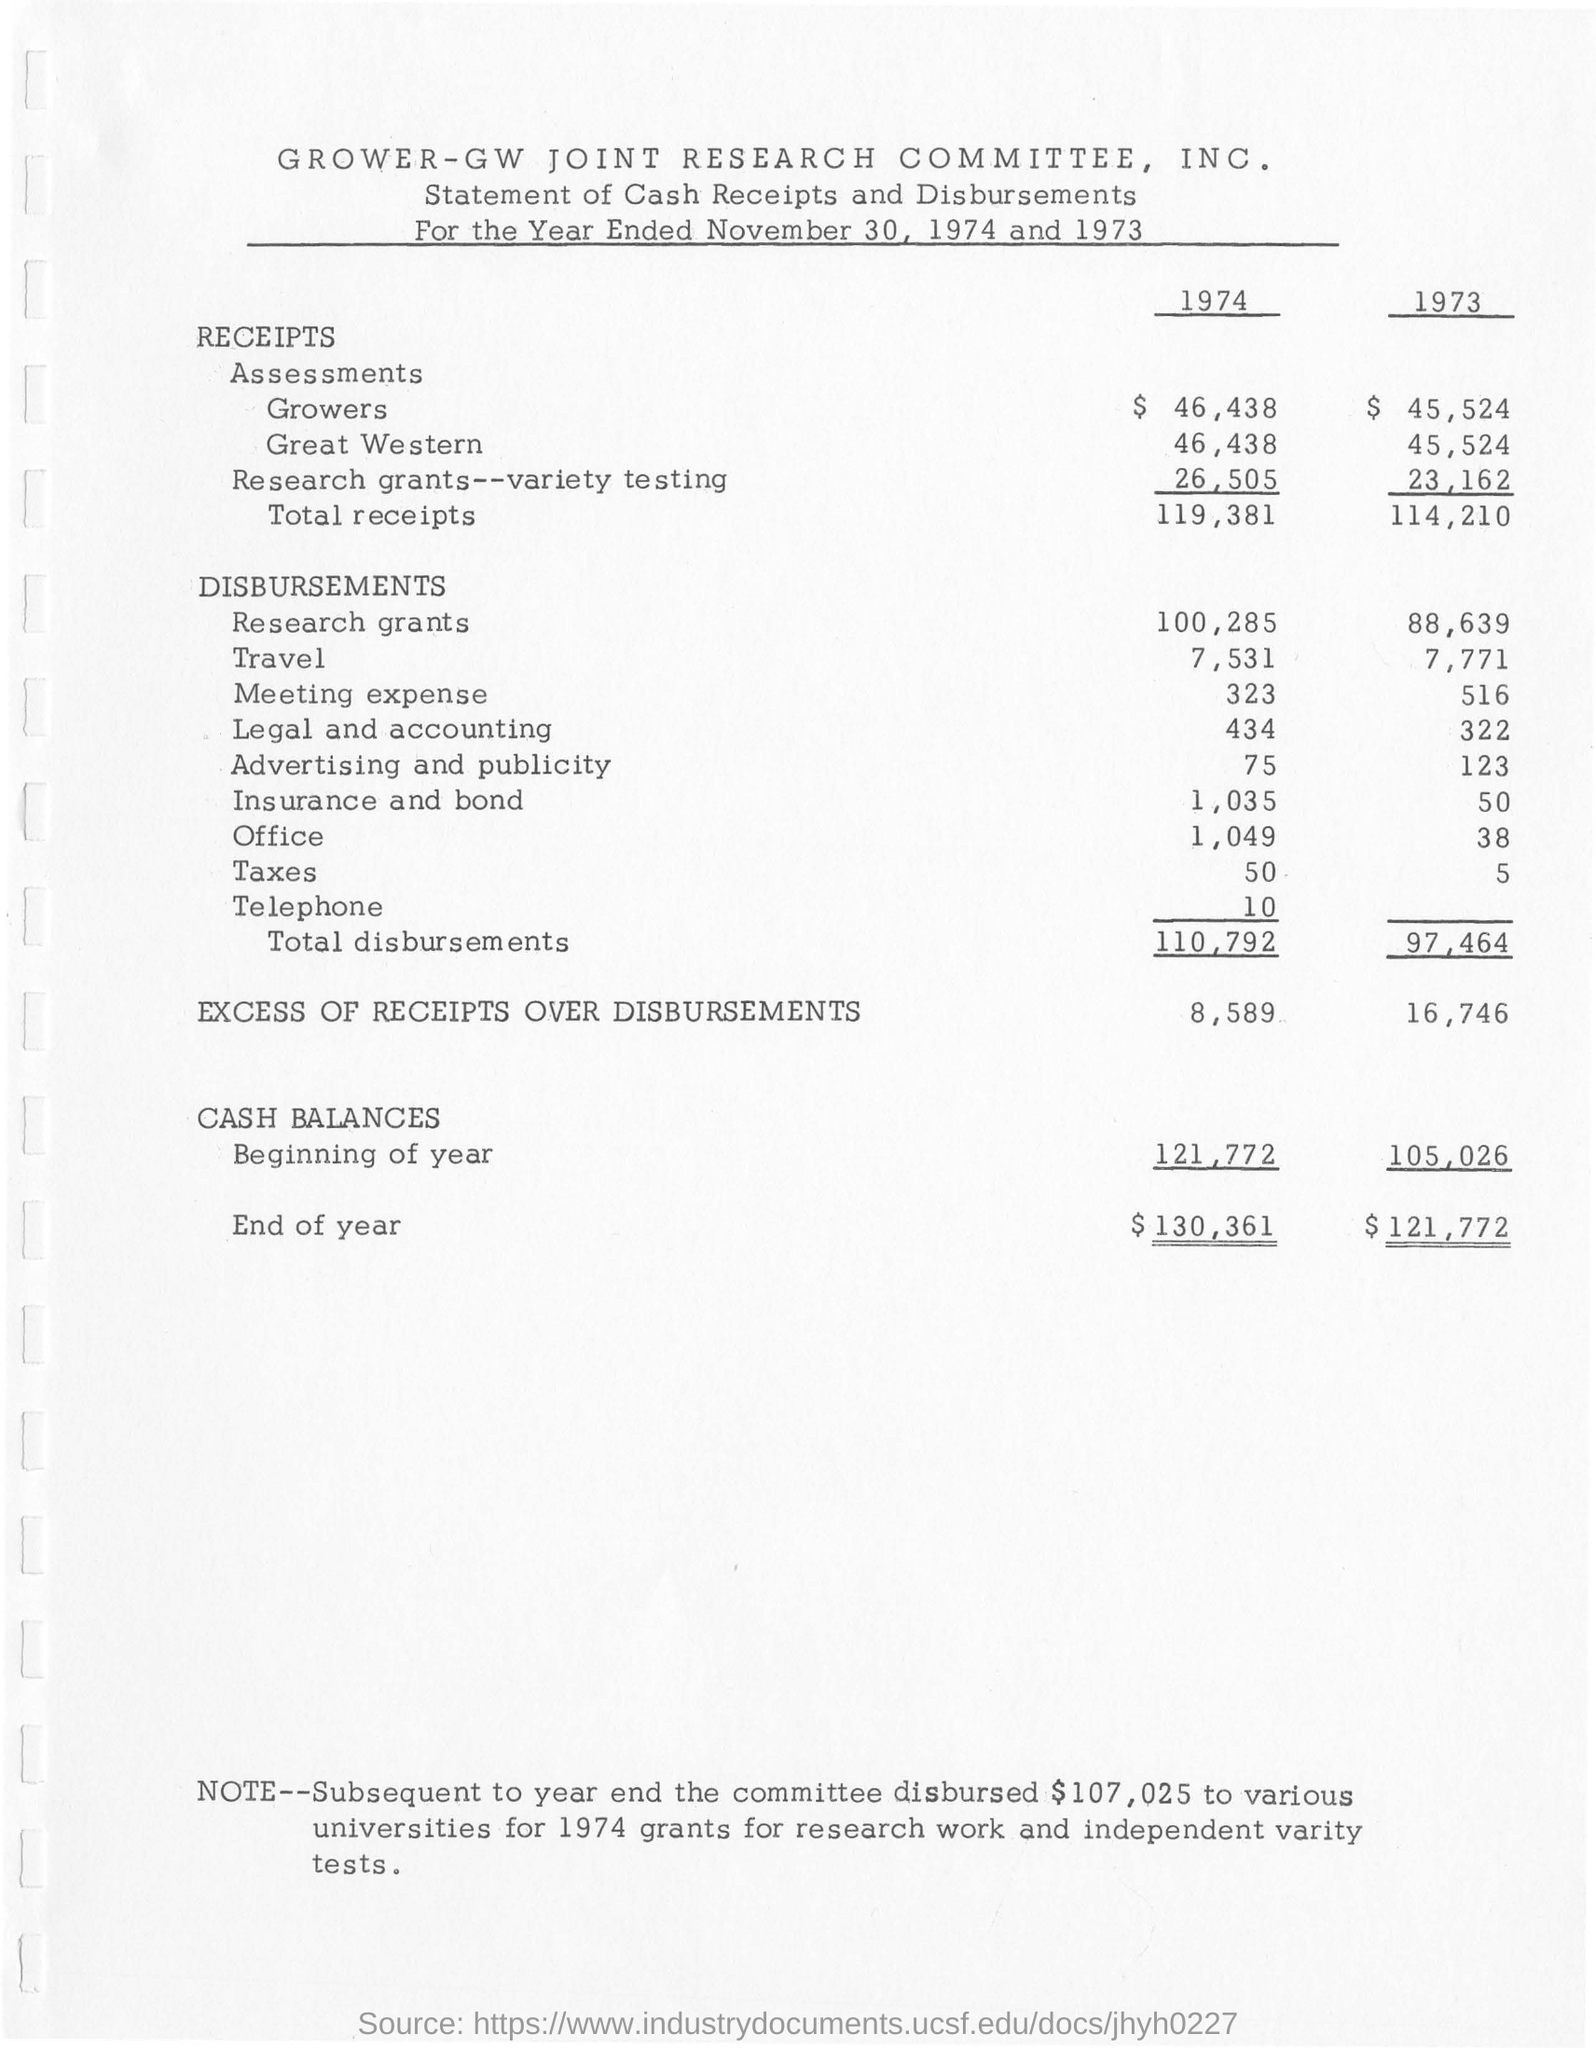Indicate a few pertinent items in this graphic. In the year 1974, the excess of receipts over disbursements amounted to 8,589. The total disbursements in the year 1973 were 97,464. In the beginning of the year 1974, the cash balances were valued at 121,772. The cash balances at the end of the year 1974 were $130,361. 